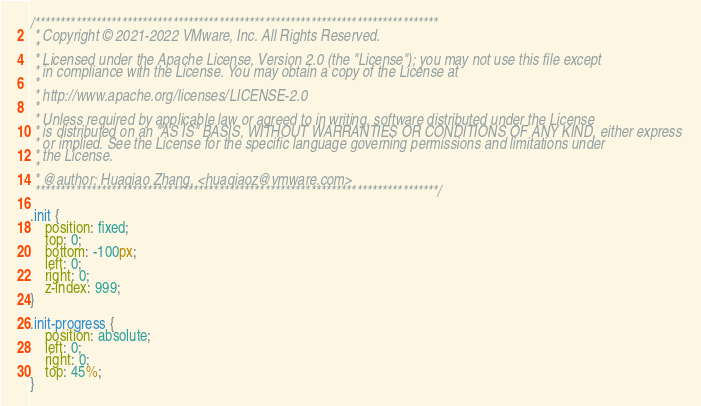Convert code to text. <code><loc_0><loc_0><loc_500><loc_500><_CSS_>/*******************************************************************************
 * Copyright © 2021-2022 VMware, Inc. All Rights Reserved.
 *
 * Licensed under the Apache License, Version 2.0 (the "License"); you may not use this file except
 * in compliance with the License. You may obtain a copy of the License at
 *
 * http://www.apache.org/licenses/LICENSE-2.0
 *
 * Unless required by applicable law or agreed to in writing, software distributed under the License
 * is distributed on an "AS IS" BASIS, WITHOUT WARRANTIES OR CONDITIONS OF ANY KIND, either express
 * or implied. See the License for the specific language governing permissions and limitations under
 * the License.
 * 
 * @author: Huaqiao Zhang, <huaqiaoz@vmware.com>
 *******************************************************************************/

.init {
    position: fixed;
    top: 0;
    bottom: -100px;
    left: 0;
    right: 0;
    z-index: 999;
}

.init-progress {
    position: absolute;
    left: 0;
    right: 0;
    top: 45%;
}</code> 